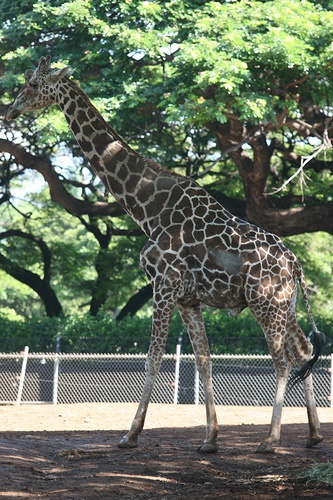Describe the objects in this image and their specific colors. I can see a giraffe in teal, gray, black, and darkgray tones in this image. 